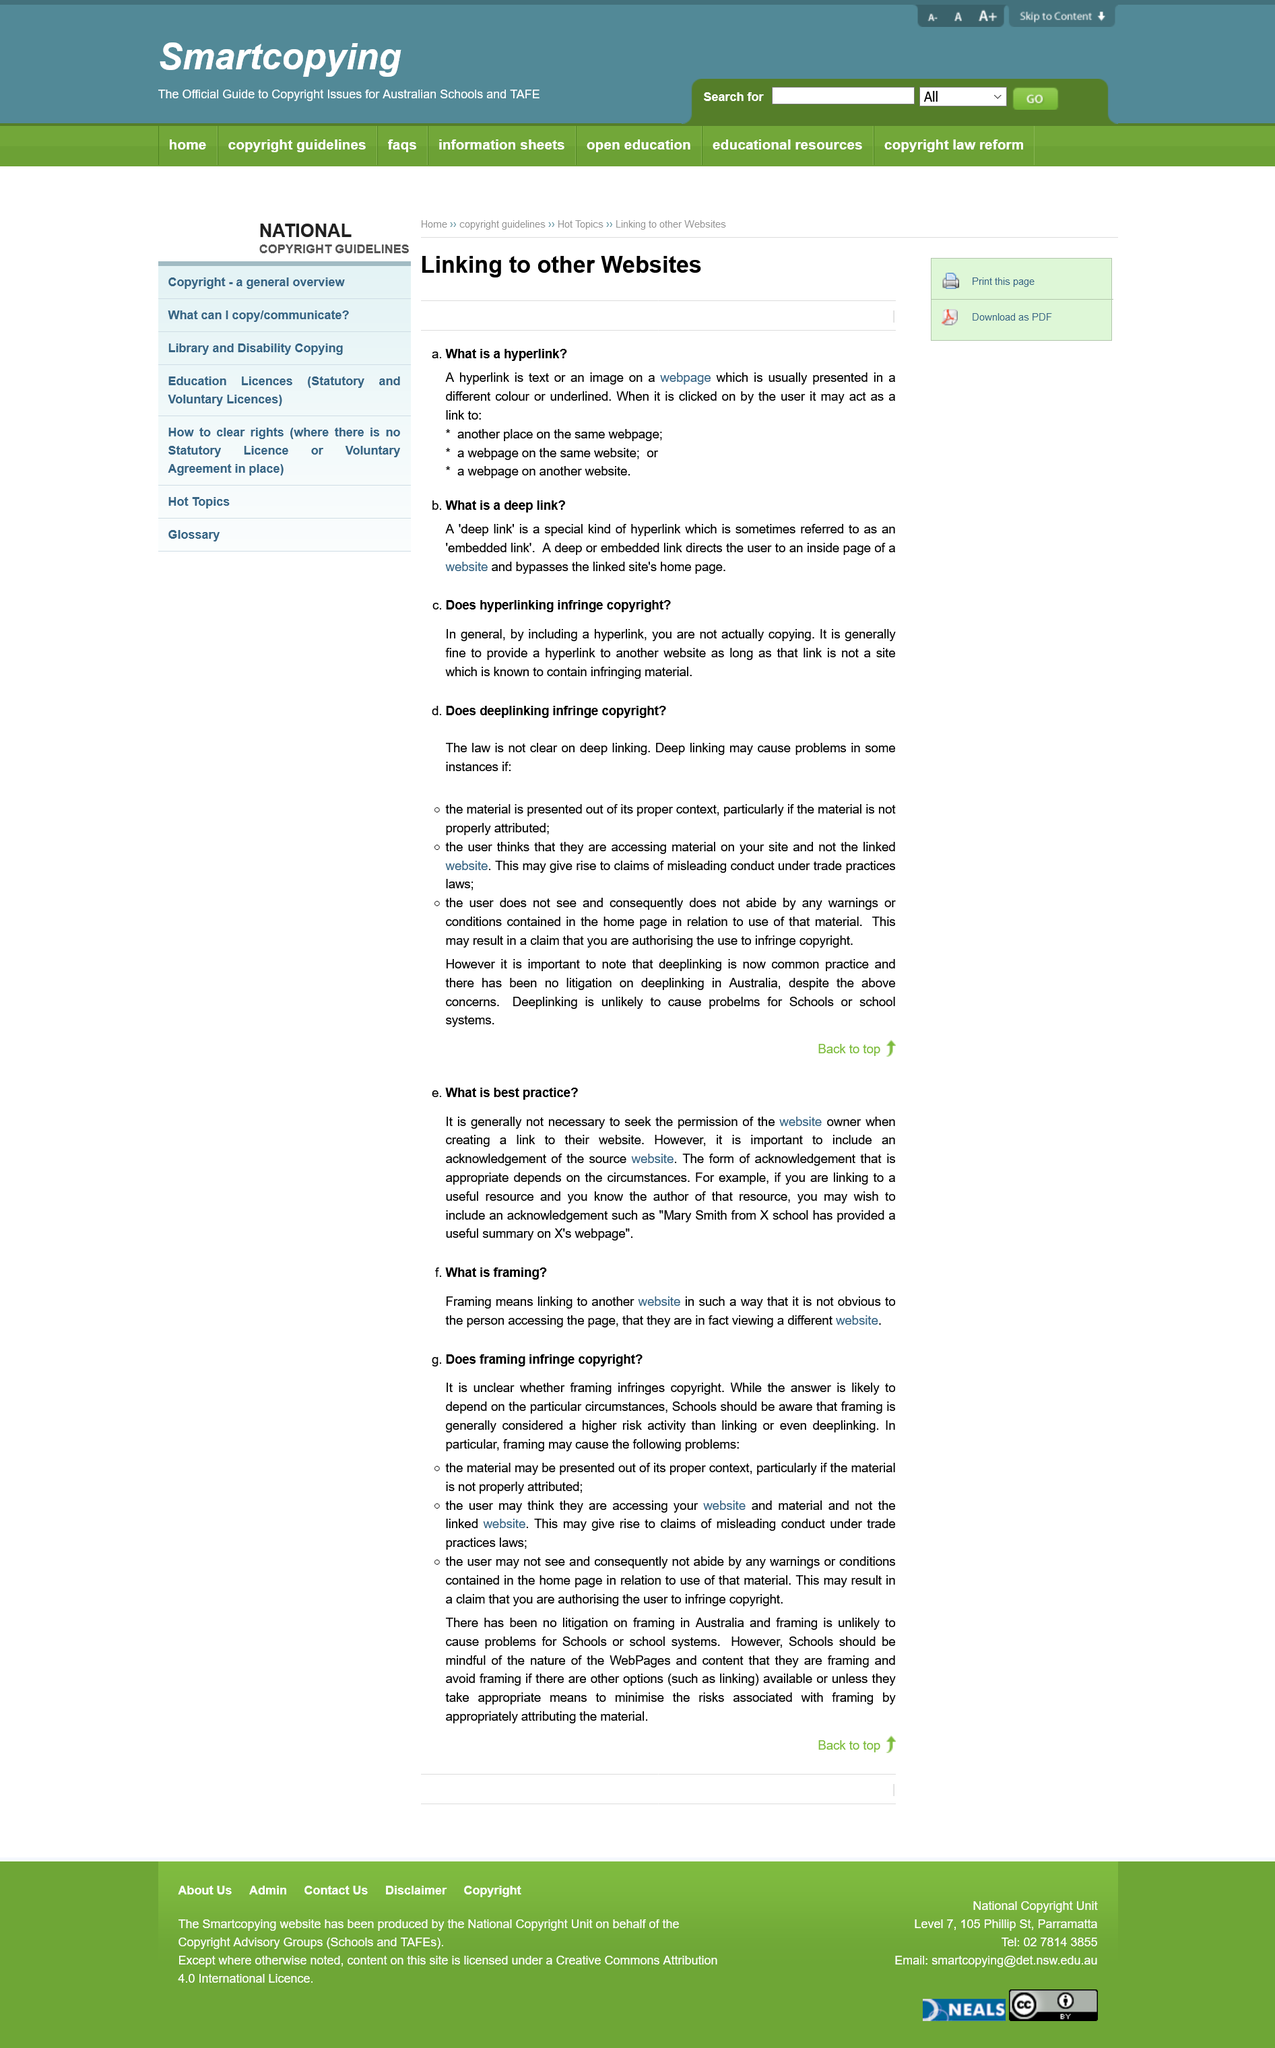Give some essential details in this illustration. A hyperlink is a text or image on a website that creates a direct connection to another webpage or specific location on the same webpage when clicked. Deep linking can cause problems if the material is presented out of context, if the user thinks they are accessing material on their site, or the user does not abide by warnings or conditions in relation to use of that material. The copyright status of a school using framing is a case-by-case basis that depends on the unique circumstances. It is not necessary to seek permission from the website owner when creating a link to their website. Framing can lead to issues where users mistakenly believe that the material originates from the website from which it is framed, rather than the actual linked website. 